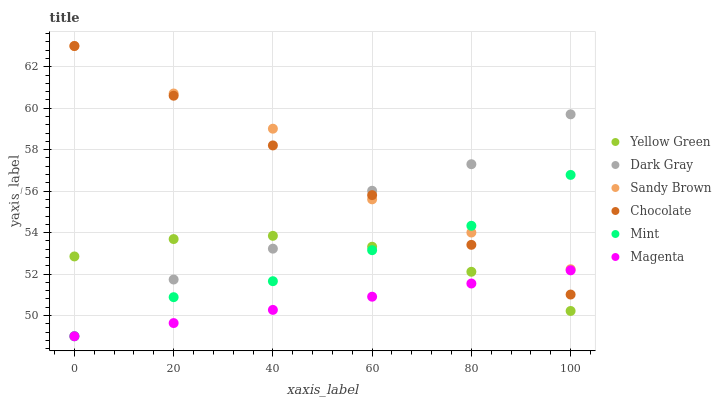Does Magenta have the minimum area under the curve?
Answer yes or no. Yes. Does Sandy Brown have the maximum area under the curve?
Answer yes or no. Yes. Does Chocolate have the minimum area under the curve?
Answer yes or no. No. Does Chocolate have the maximum area under the curve?
Answer yes or no. No. Is Magenta the smoothest?
Answer yes or no. Yes. Is Dark Gray the roughest?
Answer yes or no. Yes. Is Sandy Brown the smoothest?
Answer yes or no. No. Is Sandy Brown the roughest?
Answer yes or no. No. Does Dark Gray have the lowest value?
Answer yes or no. Yes. Does Chocolate have the lowest value?
Answer yes or no. No. Does Chocolate have the highest value?
Answer yes or no. Yes. Does Dark Gray have the highest value?
Answer yes or no. No. Is Yellow Green less than Sandy Brown?
Answer yes or no. Yes. Is Sandy Brown greater than Magenta?
Answer yes or no. Yes. Does Magenta intersect Chocolate?
Answer yes or no. Yes. Is Magenta less than Chocolate?
Answer yes or no. No. Is Magenta greater than Chocolate?
Answer yes or no. No. Does Yellow Green intersect Sandy Brown?
Answer yes or no. No. 